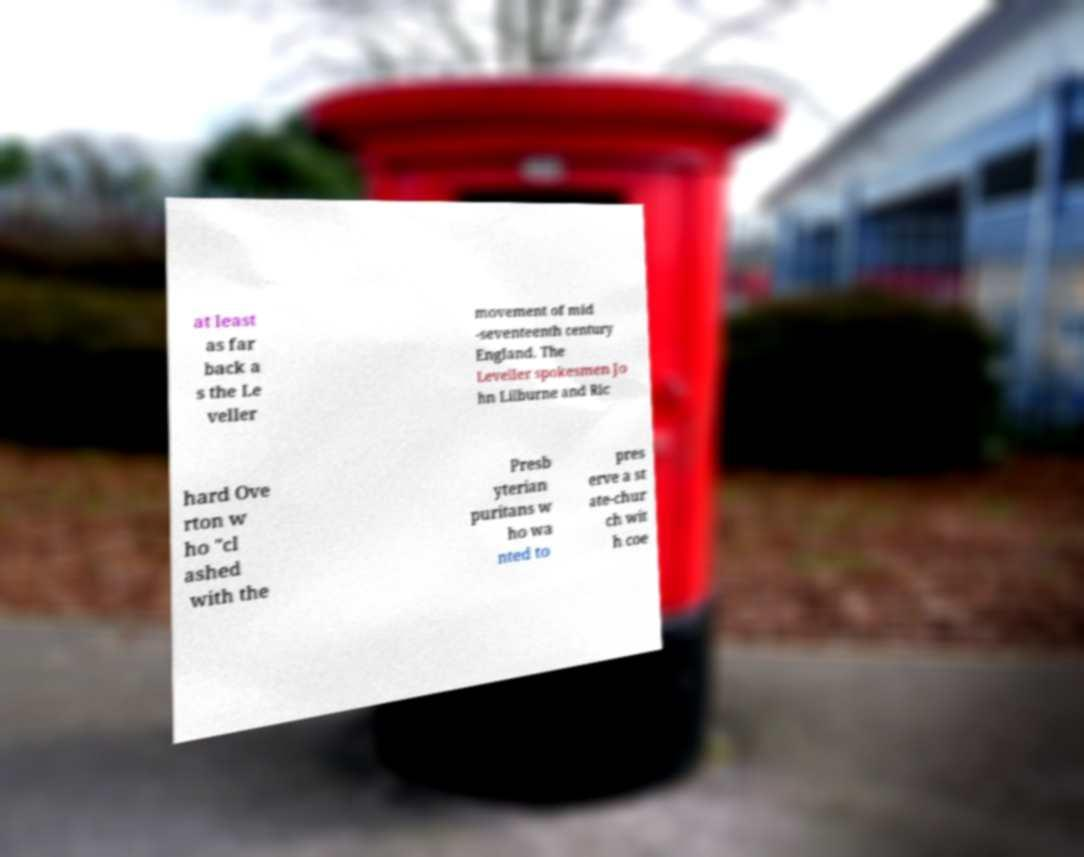For documentation purposes, I need the text within this image transcribed. Could you provide that? at least as far back a s the Le veller movement of mid -seventeenth century England. The Leveller spokesmen Jo hn Lilburne and Ric hard Ove rton w ho "cl ashed with the Presb yterian puritans w ho wa nted to pres erve a st ate-chur ch wit h coe 